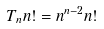<formula> <loc_0><loc_0><loc_500><loc_500>T _ { n } n ! = n ^ { n - 2 } n !</formula> 